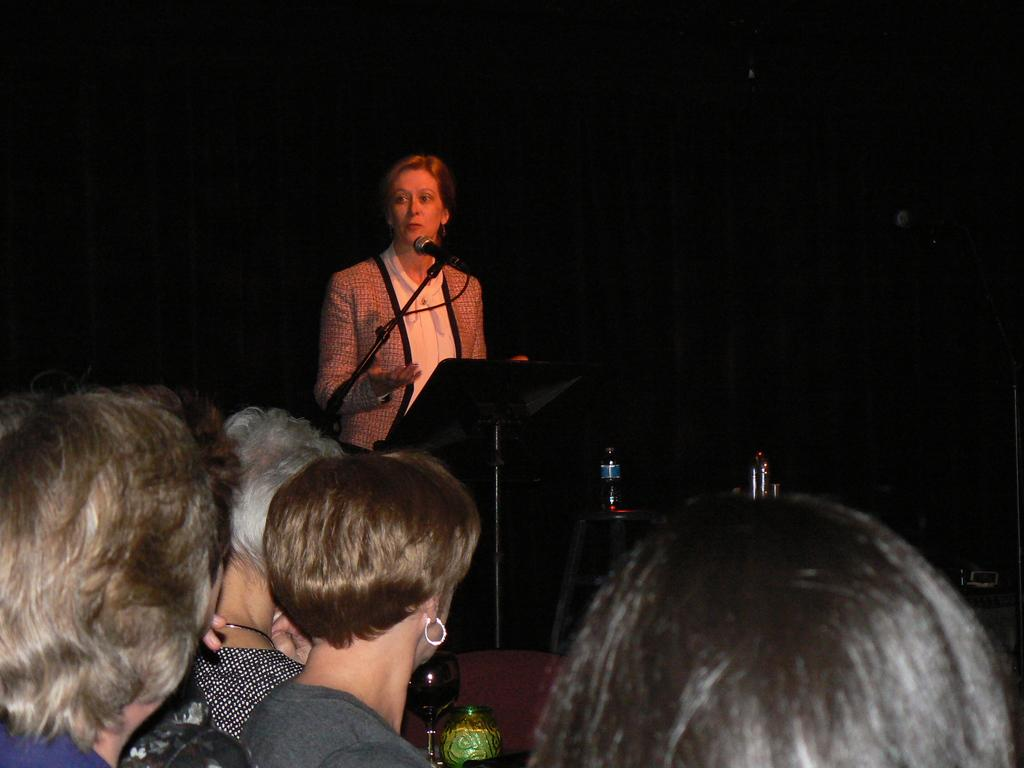How many people are in the image? There are a few people in the image. What can be seen in the image besides the people? There is a stand, a microphone, bottles, and a glass in the image. What might be used for amplifying sound in the image? The microphone in the image can be used for amplifying sound. What is the color of the background in the image? The background of the image is dark. What type of company is being represented by the bed in the image? There is no bed present in the image, so it cannot be used to represent a company. 